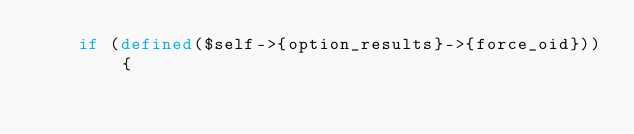<code> <loc_0><loc_0><loc_500><loc_500><_Perl_>    if (defined($self->{option_results}->{force_oid})) {</code> 